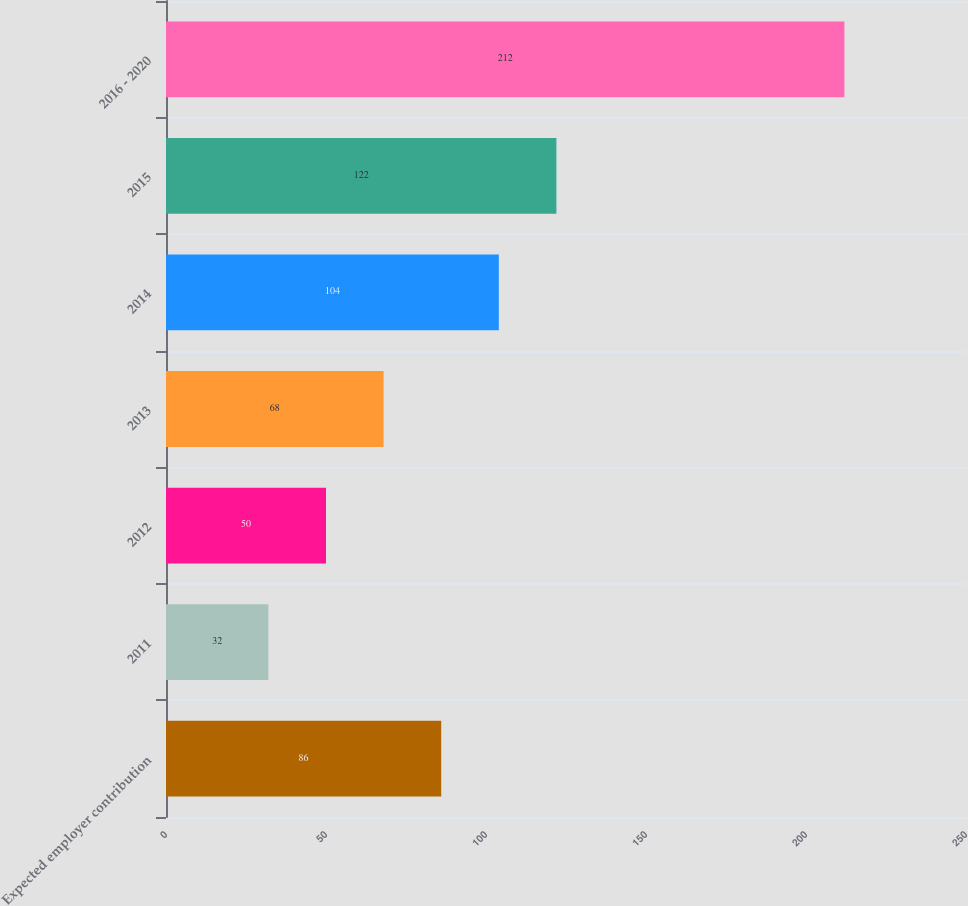Convert chart to OTSL. <chart><loc_0><loc_0><loc_500><loc_500><bar_chart><fcel>Expected employer contribution<fcel>2011<fcel>2012<fcel>2013<fcel>2014<fcel>2015<fcel>2016 - 2020<nl><fcel>86<fcel>32<fcel>50<fcel>68<fcel>104<fcel>122<fcel>212<nl></chart> 